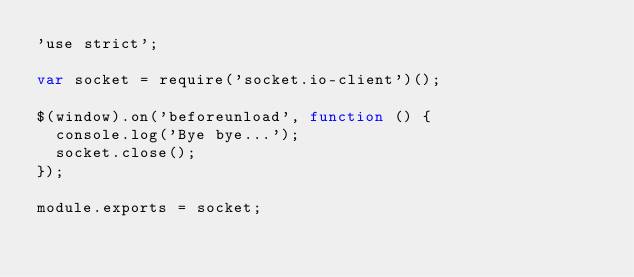Convert code to text. <code><loc_0><loc_0><loc_500><loc_500><_JavaScript_>'use strict';

var socket = require('socket.io-client')();

$(window).on('beforeunload', function () {
  console.log('Bye bye...');
  socket.close();
});

module.exports = socket;
</code> 